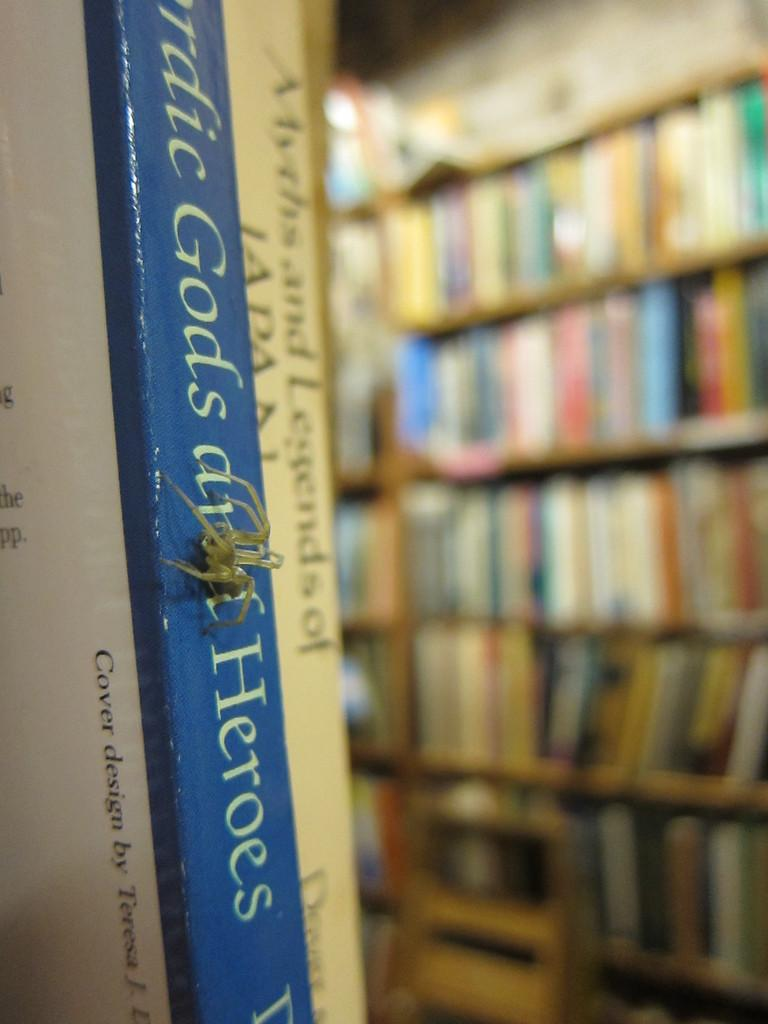<image>
Render a clear and concise summary of the photo. A book has the word heroes on the binding. 